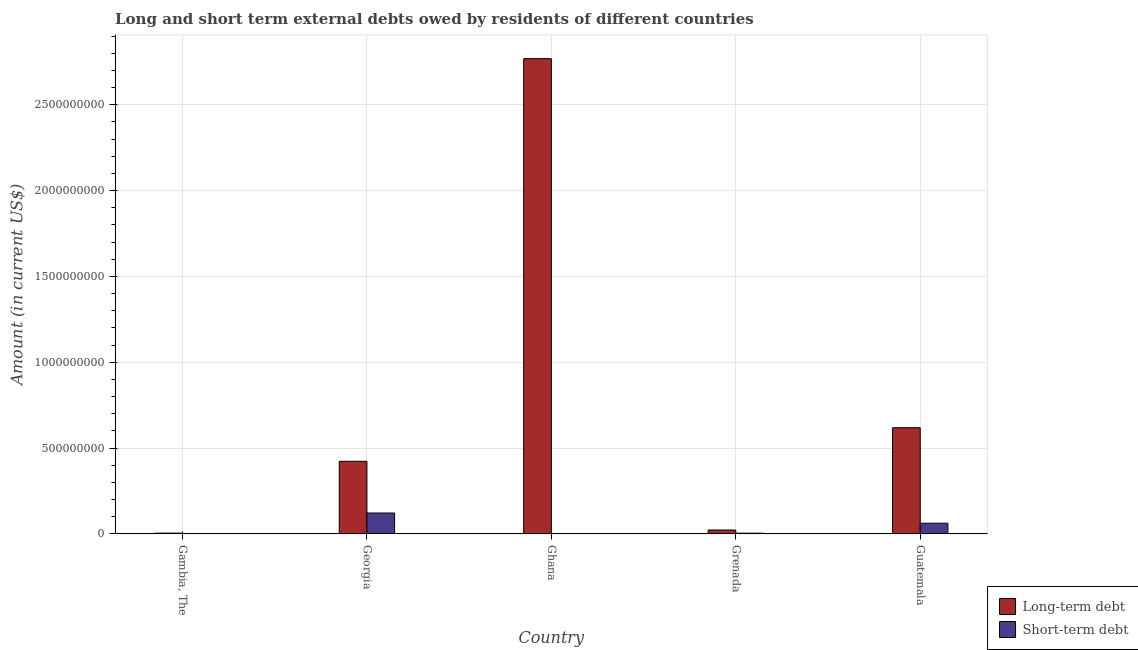How many different coloured bars are there?
Offer a very short reply. 2. How many bars are there on the 3rd tick from the left?
Make the answer very short. 1. How many bars are there on the 5th tick from the right?
Provide a succinct answer. 1. What is the label of the 3rd group of bars from the left?
Give a very brief answer. Ghana. In how many cases, is the number of bars for a given country not equal to the number of legend labels?
Offer a terse response. 2. What is the long-term debts owed by residents in Georgia?
Your answer should be very brief. 4.23e+08. Across all countries, what is the maximum long-term debts owed by residents?
Make the answer very short. 2.77e+09. Across all countries, what is the minimum short-term debts owed by residents?
Give a very brief answer. 0. In which country was the short-term debts owed by residents maximum?
Your answer should be very brief. Georgia. What is the total long-term debts owed by residents in the graph?
Offer a terse response. 3.84e+09. What is the difference between the long-term debts owed by residents in Gambia, The and that in Georgia?
Your answer should be very brief. -4.18e+08. What is the difference between the long-term debts owed by residents in Grenada and the short-term debts owed by residents in Guatemala?
Offer a very short reply. -3.95e+07. What is the average long-term debts owed by residents per country?
Your response must be concise. 7.67e+08. What is the difference between the short-term debts owed by residents and long-term debts owed by residents in Georgia?
Offer a terse response. -3.01e+08. In how many countries, is the long-term debts owed by residents greater than 900000000 US$?
Offer a terse response. 1. What is the ratio of the short-term debts owed by residents in Georgia to that in Guatemala?
Offer a terse response. 1.96. Is the difference between the long-term debts owed by residents in Georgia and Grenada greater than the difference between the short-term debts owed by residents in Georgia and Grenada?
Your answer should be very brief. Yes. What is the difference between the highest and the second highest long-term debts owed by residents?
Keep it short and to the point. 2.15e+09. What is the difference between the highest and the lowest short-term debts owed by residents?
Your response must be concise. 1.21e+08. In how many countries, is the short-term debts owed by residents greater than the average short-term debts owed by residents taken over all countries?
Provide a short and direct response. 2. Is the sum of the long-term debts owed by residents in Georgia and Guatemala greater than the maximum short-term debts owed by residents across all countries?
Make the answer very short. Yes. How many bars are there?
Provide a short and direct response. 8. Are all the bars in the graph horizontal?
Your answer should be very brief. No. Does the graph contain grids?
Your response must be concise. Yes. How many legend labels are there?
Ensure brevity in your answer.  2. How are the legend labels stacked?
Your answer should be very brief. Vertical. What is the title of the graph?
Offer a terse response. Long and short term external debts owed by residents of different countries. Does "Borrowers" appear as one of the legend labels in the graph?
Provide a short and direct response. No. What is the label or title of the X-axis?
Offer a terse response. Country. What is the Amount (in current US$) in Long-term debt in Gambia, The?
Give a very brief answer. 4.38e+06. What is the Amount (in current US$) in Short-term debt in Gambia, The?
Offer a terse response. 0. What is the Amount (in current US$) in Long-term debt in Georgia?
Offer a terse response. 4.23e+08. What is the Amount (in current US$) in Short-term debt in Georgia?
Your answer should be compact. 1.21e+08. What is the Amount (in current US$) in Long-term debt in Ghana?
Offer a terse response. 2.77e+09. What is the Amount (in current US$) in Short-term debt in Ghana?
Your response must be concise. 0. What is the Amount (in current US$) in Long-term debt in Grenada?
Offer a terse response. 2.25e+07. What is the Amount (in current US$) of Long-term debt in Guatemala?
Your response must be concise. 6.18e+08. What is the Amount (in current US$) of Short-term debt in Guatemala?
Give a very brief answer. 6.20e+07. Across all countries, what is the maximum Amount (in current US$) in Long-term debt?
Give a very brief answer. 2.77e+09. Across all countries, what is the maximum Amount (in current US$) in Short-term debt?
Keep it short and to the point. 1.21e+08. Across all countries, what is the minimum Amount (in current US$) of Long-term debt?
Ensure brevity in your answer.  4.38e+06. What is the total Amount (in current US$) of Long-term debt in the graph?
Provide a short and direct response. 3.84e+09. What is the total Amount (in current US$) of Short-term debt in the graph?
Offer a terse response. 1.87e+08. What is the difference between the Amount (in current US$) of Long-term debt in Gambia, The and that in Georgia?
Make the answer very short. -4.18e+08. What is the difference between the Amount (in current US$) in Long-term debt in Gambia, The and that in Ghana?
Your response must be concise. -2.76e+09. What is the difference between the Amount (in current US$) of Long-term debt in Gambia, The and that in Grenada?
Your answer should be very brief. -1.81e+07. What is the difference between the Amount (in current US$) in Long-term debt in Gambia, The and that in Guatemala?
Your answer should be very brief. -6.14e+08. What is the difference between the Amount (in current US$) in Long-term debt in Georgia and that in Ghana?
Provide a succinct answer. -2.35e+09. What is the difference between the Amount (in current US$) in Long-term debt in Georgia and that in Grenada?
Your answer should be compact. 4.00e+08. What is the difference between the Amount (in current US$) of Short-term debt in Georgia and that in Grenada?
Provide a short and direct response. 1.17e+08. What is the difference between the Amount (in current US$) in Long-term debt in Georgia and that in Guatemala?
Your answer should be compact. -1.96e+08. What is the difference between the Amount (in current US$) of Short-term debt in Georgia and that in Guatemala?
Your answer should be very brief. 5.93e+07. What is the difference between the Amount (in current US$) in Long-term debt in Ghana and that in Grenada?
Keep it short and to the point. 2.75e+09. What is the difference between the Amount (in current US$) of Long-term debt in Ghana and that in Guatemala?
Make the answer very short. 2.15e+09. What is the difference between the Amount (in current US$) of Long-term debt in Grenada and that in Guatemala?
Keep it short and to the point. -5.96e+08. What is the difference between the Amount (in current US$) of Short-term debt in Grenada and that in Guatemala?
Your response must be concise. -5.80e+07. What is the difference between the Amount (in current US$) of Long-term debt in Gambia, The and the Amount (in current US$) of Short-term debt in Georgia?
Offer a very short reply. -1.17e+08. What is the difference between the Amount (in current US$) of Long-term debt in Gambia, The and the Amount (in current US$) of Short-term debt in Grenada?
Offer a terse response. 3.80e+05. What is the difference between the Amount (in current US$) in Long-term debt in Gambia, The and the Amount (in current US$) in Short-term debt in Guatemala?
Keep it short and to the point. -5.76e+07. What is the difference between the Amount (in current US$) in Long-term debt in Georgia and the Amount (in current US$) in Short-term debt in Grenada?
Provide a succinct answer. 4.19e+08. What is the difference between the Amount (in current US$) in Long-term debt in Georgia and the Amount (in current US$) in Short-term debt in Guatemala?
Give a very brief answer. 3.61e+08. What is the difference between the Amount (in current US$) of Long-term debt in Ghana and the Amount (in current US$) of Short-term debt in Grenada?
Provide a succinct answer. 2.76e+09. What is the difference between the Amount (in current US$) in Long-term debt in Ghana and the Amount (in current US$) in Short-term debt in Guatemala?
Ensure brevity in your answer.  2.71e+09. What is the difference between the Amount (in current US$) in Long-term debt in Grenada and the Amount (in current US$) in Short-term debt in Guatemala?
Your answer should be very brief. -3.95e+07. What is the average Amount (in current US$) of Long-term debt per country?
Make the answer very short. 7.67e+08. What is the average Amount (in current US$) of Short-term debt per country?
Offer a very short reply. 3.75e+07. What is the difference between the Amount (in current US$) in Long-term debt and Amount (in current US$) in Short-term debt in Georgia?
Offer a terse response. 3.01e+08. What is the difference between the Amount (in current US$) of Long-term debt and Amount (in current US$) of Short-term debt in Grenada?
Provide a succinct answer. 1.85e+07. What is the difference between the Amount (in current US$) of Long-term debt and Amount (in current US$) of Short-term debt in Guatemala?
Give a very brief answer. 5.56e+08. What is the ratio of the Amount (in current US$) in Long-term debt in Gambia, The to that in Georgia?
Give a very brief answer. 0.01. What is the ratio of the Amount (in current US$) of Long-term debt in Gambia, The to that in Ghana?
Keep it short and to the point. 0. What is the ratio of the Amount (in current US$) of Long-term debt in Gambia, The to that in Grenada?
Offer a very short reply. 0.2. What is the ratio of the Amount (in current US$) of Long-term debt in Gambia, The to that in Guatemala?
Keep it short and to the point. 0.01. What is the ratio of the Amount (in current US$) of Long-term debt in Georgia to that in Ghana?
Your answer should be compact. 0.15. What is the ratio of the Amount (in current US$) in Long-term debt in Georgia to that in Grenada?
Keep it short and to the point. 18.82. What is the ratio of the Amount (in current US$) of Short-term debt in Georgia to that in Grenada?
Your answer should be very brief. 30.34. What is the ratio of the Amount (in current US$) of Long-term debt in Georgia to that in Guatemala?
Your answer should be very brief. 0.68. What is the ratio of the Amount (in current US$) in Short-term debt in Georgia to that in Guatemala?
Give a very brief answer. 1.96. What is the ratio of the Amount (in current US$) of Long-term debt in Ghana to that in Grenada?
Your response must be concise. 123.23. What is the ratio of the Amount (in current US$) in Long-term debt in Ghana to that in Guatemala?
Make the answer very short. 4.48. What is the ratio of the Amount (in current US$) of Long-term debt in Grenada to that in Guatemala?
Offer a very short reply. 0.04. What is the ratio of the Amount (in current US$) of Short-term debt in Grenada to that in Guatemala?
Keep it short and to the point. 0.06. What is the difference between the highest and the second highest Amount (in current US$) in Long-term debt?
Provide a succinct answer. 2.15e+09. What is the difference between the highest and the second highest Amount (in current US$) of Short-term debt?
Ensure brevity in your answer.  5.93e+07. What is the difference between the highest and the lowest Amount (in current US$) of Long-term debt?
Provide a succinct answer. 2.76e+09. What is the difference between the highest and the lowest Amount (in current US$) in Short-term debt?
Your answer should be very brief. 1.21e+08. 